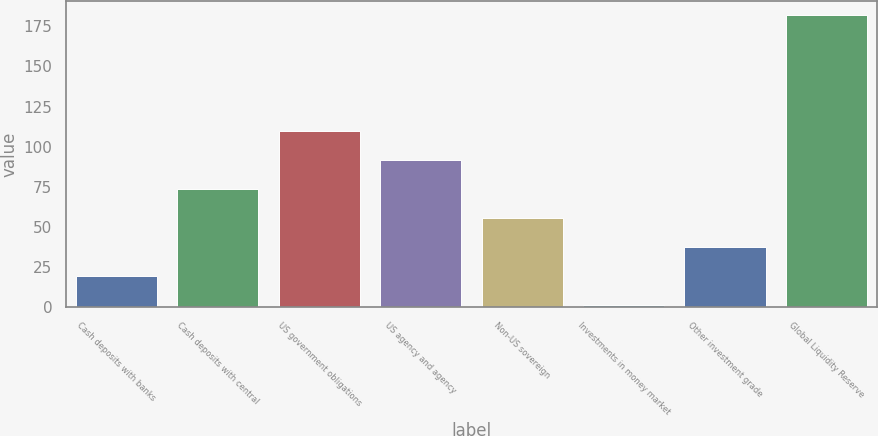<chart> <loc_0><loc_0><loc_500><loc_500><bar_chart><fcel>Cash deposits with banks<fcel>Cash deposits with central<fcel>US government obligations<fcel>US agency and agency<fcel>Non-US sovereign<fcel>Investments in money market<fcel>Other investment grade<fcel>Global Liquidity Reserve<nl><fcel>19.1<fcel>73.4<fcel>109.6<fcel>91.5<fcel>55.3<fcel>1<fcel>37.2<fcel>182<nl></chart> 